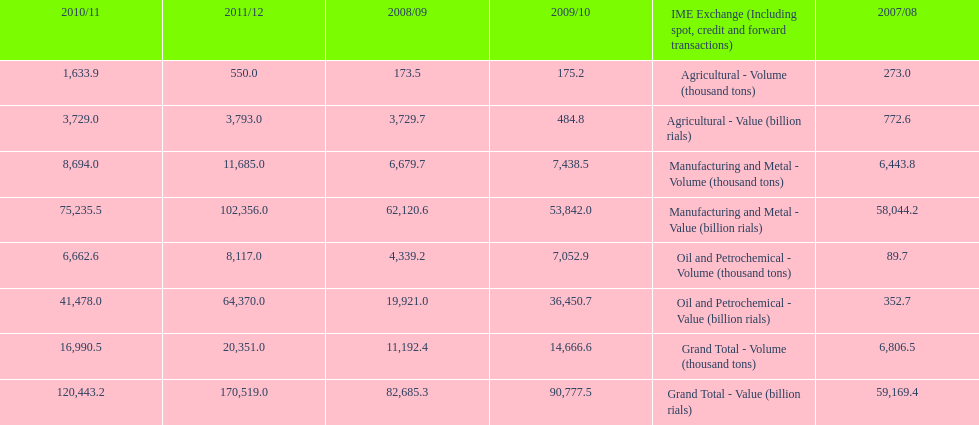What year saw the greatest value for manufacturing and metal in iran? 2011/12. 